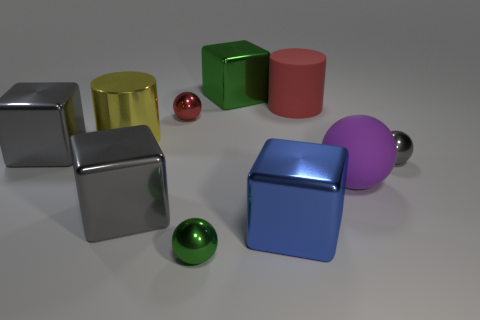Subtract 1 cubes. How many cubes are left? 3 Subtract all cylinders. How many objects are left? 8 Subtract all gray cubes. Subtract all green spheres. How many objects are left? 7 Add 3 big metal objects. How many big metal objects are left? 8 Add 4 big red matte objects. How many big red matte objects exist? 5 Subtract 0 purple blocks. How many objects are left? 10 